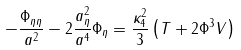<formula> <loc_0><loc_0><loc_500><loc_500>- \frac { \Phi _ { \eta \eta } } { a ^ { 2 } } - 2 \frac { a _ { \eta } ^ { 2 } } { a ^ { 4 } } \Phi _ { \eta } = \frac { \kappa _ { 4 } ^ { 2 } } { 3 } \left ( T + 2 \Phi ^ { 3 } V \right )</formula> 